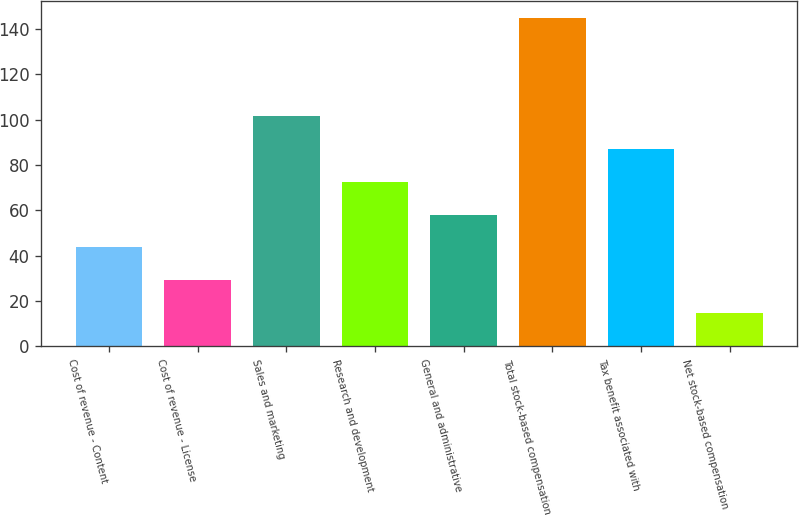Convert chart. <chart><loc_0><loc_0><loc_500><loc_500><bar_chart><fcel>Cost of revenue - Content<fcel>Cost of revenue - License<fcel>Sales and marketing<fcel>Research and development<fcel>General and administrative<fcel>Total stock-based compensation<fcel>Tax benefit associated with<fcel>Net stock-based compensation<nl><fcel>43.6<fcel>29.11<fcel>101.56<fcel>72.58<fcel>58.09<fcel>145<fcel>87.07<fcel>14.62<nl></chart> 